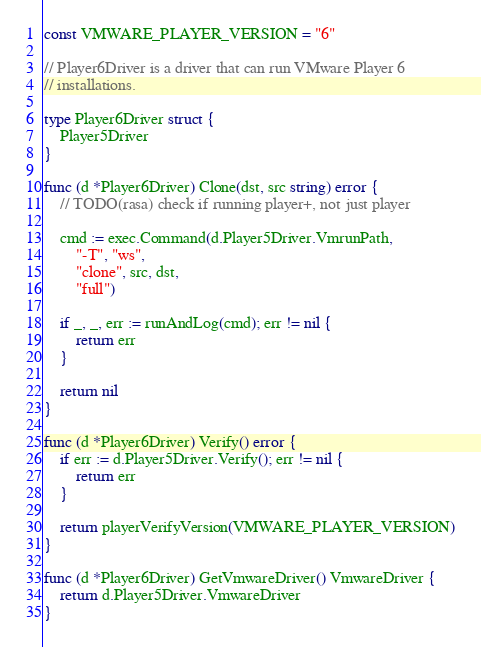<code> <loc_0><loc_0><loc_500><loc_500><_Go_>const VMWARE_PLAYER_VERSION = "6"

// Player6Driver is a driver that can run VMware Player 6
// installations.

type Player6Driver struct {
	Player5Driver
}

func (d *Player6Driver) Clone(dst, src string) error {
	// TODO(rasa) check if running player+, not just player

	cmd := exec.Command(d.Player5Driver.VmrunPath,
		"-T", "ws",
		"clone", src, dst,
		"full")

	if _, _, err := runAndLog(cmd); err != nil {
		return err
	}

	return nil
}

func (d *Player6Driver) Verify() error {
	if err := d.Player5Driver.Verify(); err != nil {
		return err
	}

	return playerVerifyVersion(VMWARE_PLAYER_VERSION)
}

func (d *Player6Driver) GetVmwareDriver() VmwareDriver {
	return d.Player5Driver.VmwareDriver
}
</code> 